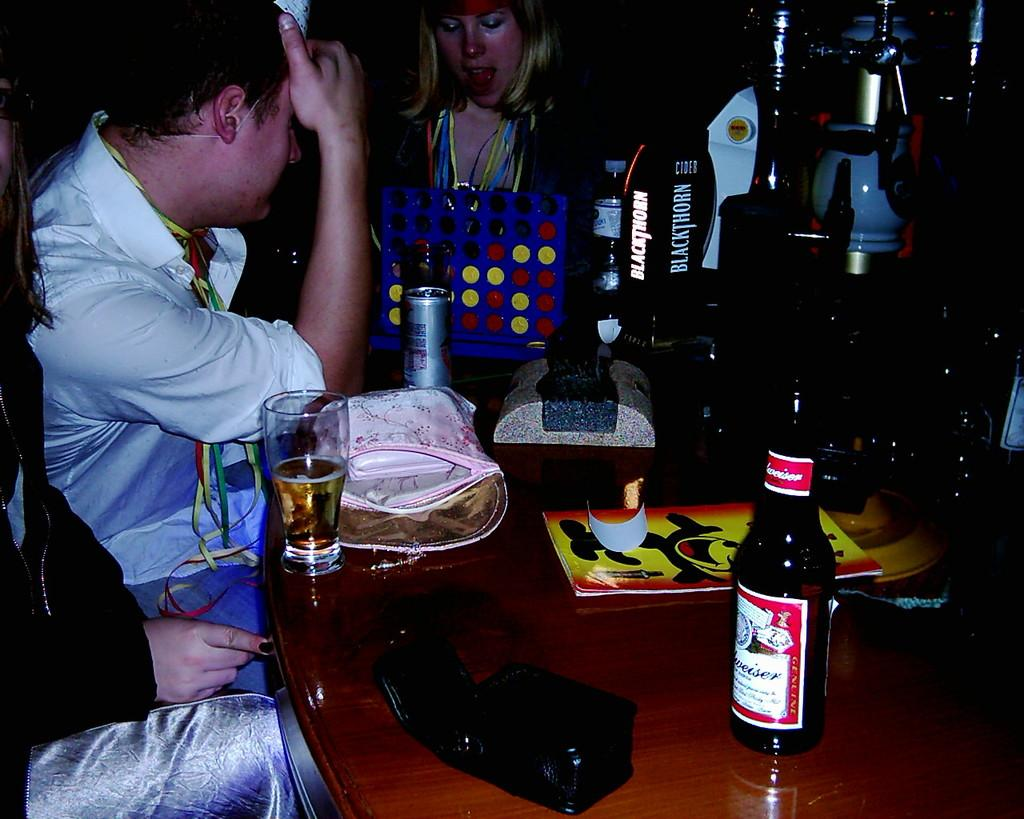How many people are in the image? There is a group of people in the image. What are the people doing in the image? The people are sitting on chairs. What is in front of the people? There is a table in front of the people. What beverages can be seen on the table? Beer and Coke tins are on the table. What type of glasses are on the table? Glasses of beer glasses of beer are on the table. What else is on the table besides beverages? Handbags are on the table. What grade does the person in the image desire to achieve? There is no indication of anyone desiring a grade in the image, as it features a group of people sitting around a table with beer, glasses, handbags, and Coke tins. 